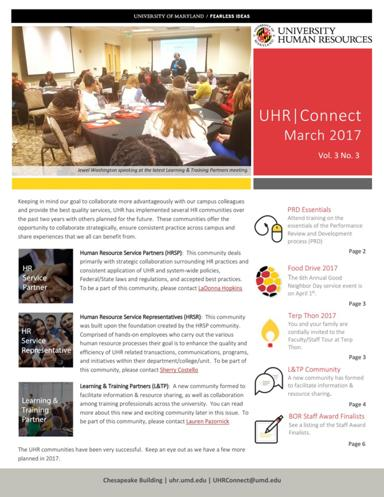Could you tell me more about the 3OR Staff Award Finalists featured in this newsletter? The 3OR Staff Award Finalists section in the newsletter recognizes outstanding staff members who have significantly contributed to their departments. This award highlights their exemplary performance, showcasing their dedication and impact within the university. 